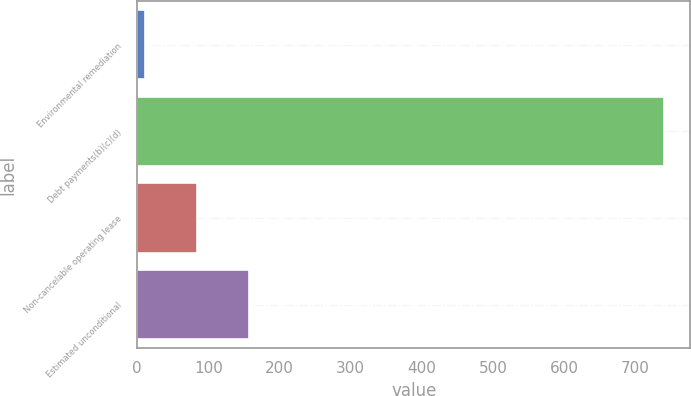Convert chart to OTSL. <chart><loc_0><loc_0><loc_500><loc_500><bar_chart><fcel>Environmental remediation<fcel>Debt payments(b)(c)(d)<fcel>Non-cancelable operating lease<fcel>Estimated unconditional<nl><fcel>11<fcel>740<fcel>83.9<fcel>156.8<nl></chart> 